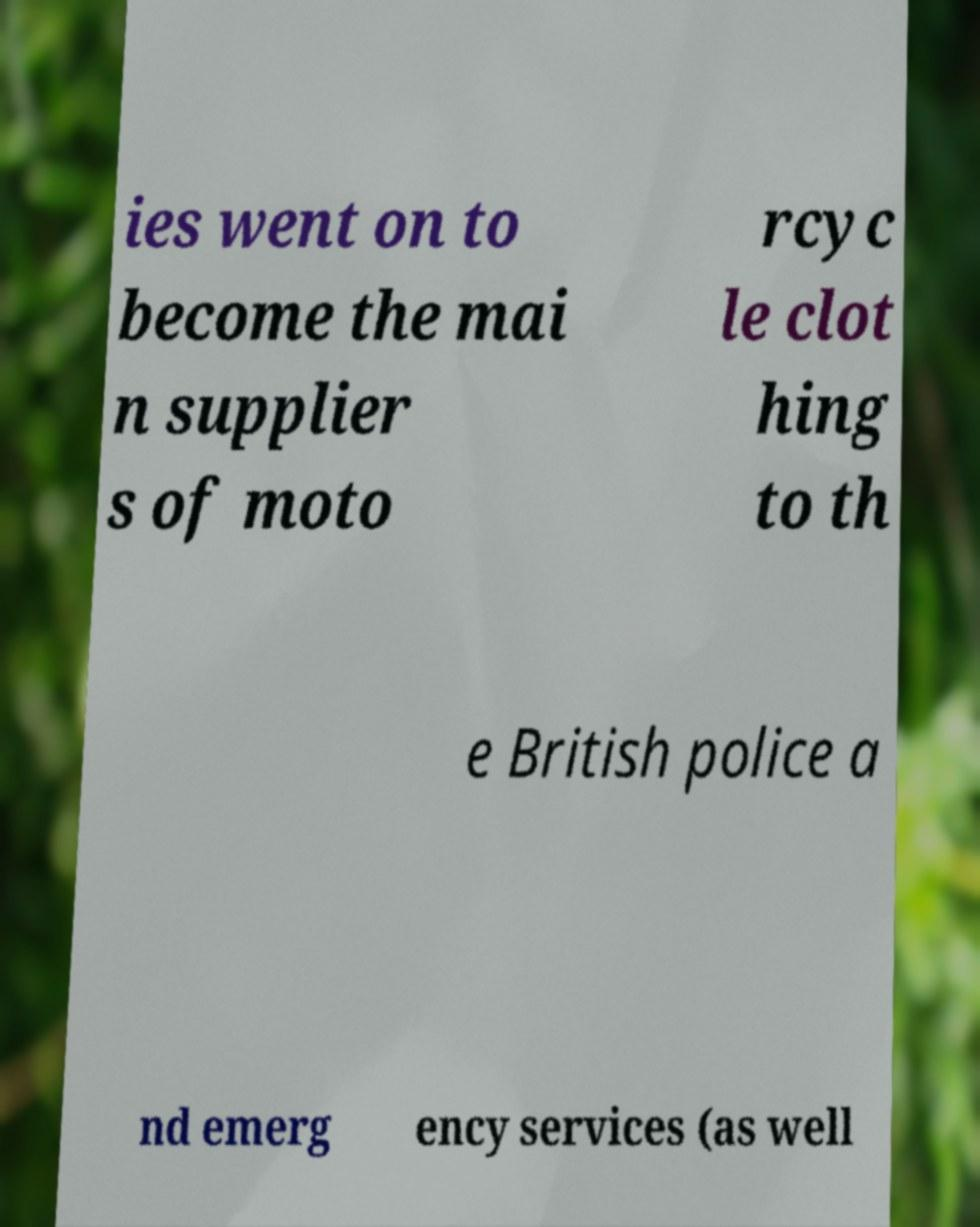For documentation purposes, I need the text within this image transcribed. Could you provide that? ies went on to become the mai n supplier s of moto rcyc le clot hing to th e British police a nd emerg ency services (as well 